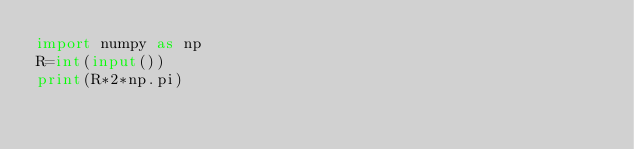<code> <loc_0><loc_0><loc_500><loc_500><_Python_>import numpy as np
R=int(input())
print(R*2*np.pi)</code> 